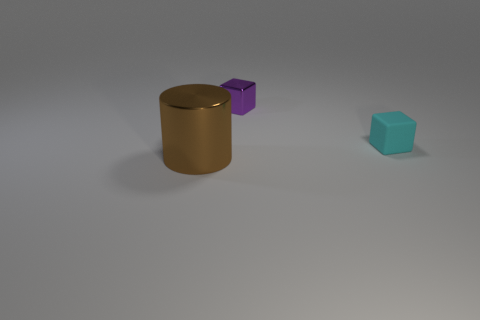There is a metal thing that is in front of the shiny thing to the right of the brown cylinder; how big is it?
Your answer should be compact. Large. The brown shiny object has what shape?
Your response must be concise. Cylinder. What number of small things are brown metal cylinders or purple metal balls?
Your response must be concise. 0. The other object that is the same shape as the small cyan object is what size?
Provide a short and direct response. Small. What number of objects are both on the left side of the cyan thing and right of the large metallic thing?
Provide a short and direct response. 1. There is a cyan rubber thing; is its shape the same as the thing to the left of the purple cube?
Your response must be concise. No. Are there more matte objects that are behind the cyan rubber cube than tiny cyan things?
Your answer should be compact. No. Are there fewer small cyan matte cubes behind the small purple object than big red objects?
Keep it short and to the point. No. What number of matte cubes are the same color as the large thing?
Your answer should be compact. 0. The thing that is both on the right side of the big brown thing and on the left side of the small matte object is made of what material?
Make the answer very short. Metal. 